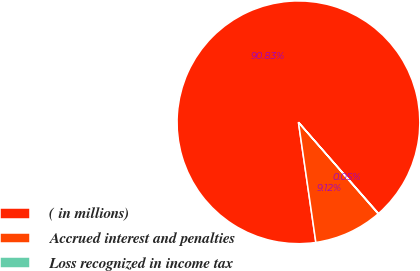<chart> <loc_0><loc_0><loc_500><loc_500><pie_chart><fcel>( in millions)<fcel>Accrued interest and penalties<fcel>Loss recognized in income tax<nl><fcel>90.83%<fcel>9.12%<fcel>0.05%<nl></chart> 